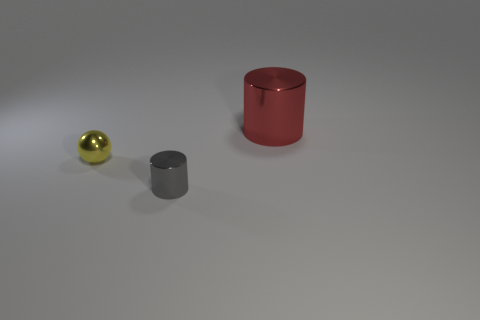Add 1 big yellow things. How many objects exist? 4 Subtract all spheres. How many objects are left? 2 Add 3 large red cylinders. How many large red cylinders are left? 4 Add 1 red metal cylinders. How many red metal cylinders exist? 2 Subtract 0 cyan cubes. How many objects are left? 3 Subtract all gray objects. Subtract all big rubber objects. How many objects are left? 2 